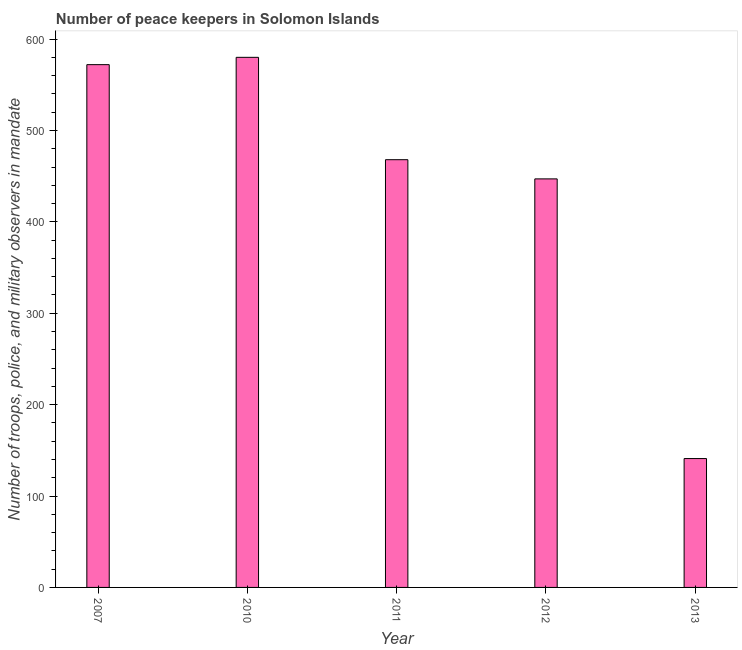Does the graph contain grids?
Your response must be concise. No. What is the title of the graph?
Give a very brief answer. Number of peace keepers in Solomon Islands. What is the label or title of the X-axis?
Keep it short and to the point. Year. What is the label or title of the Y-axis?
Provide a succinct answer. Number of troops, police, and military observers in mandate. What is the number of peace keepers in 2007?
Provide a succinct answer. 572. Across all years, what is the maximum number of peace keepers?
Provide a succinct answer. 580. Across all years, what is the minimum number of peace keepers?
Your response must be concise. 141. What is the sum of the number of peace keepers?
Your response must be concise. 2208. What is the difference between the number of peace keepers in 2007 and 2013?
Provide a short and direct response. 431. What is the average number of peace keepers per year?
Provide a short and direct response. 441. What is the median number of peace keepers?
Make the answer very short. 468. In how many years, is the number of peace keepers greater than 60 ?
Provide a short and direct response. 5. Do a majority of the years between 2010 and 2012 (inclusive) have number of peace keepers greater than 160 ?
Ensure brevity in your answer.  Yes. What is the ratio of the number of peace keepers in 2007 to that in 2013?
Give a very brief answer. 4.06. Is the number of peace keepers in 2007 less than that in 2012?
Offer a terse response. No. What is the difference between the highest and the lowest number of peace keepers?
Give a very brief answer. 439. In how many years, is the number of peace keepers greater than the average number of peace keepers taken over all years?
Provide a short and direct response. 4. Are all the bars in the graph horizontal?
Ensure brevity in your answer.  No. What is the difference between two consecutive major ticks on the Y-axis?
Your response must be concise. 100. Are the values on the major ticks of Y-axis written in scientific E-notation?
Your answer should be compact. No. What is the Number of troops, police, and military observers in mandate of 2007?
Your answer should be very brief. 572. What is the Number of troops, police, and military observers in mandate of 2010?
Your answer should be very brief. 580. What is the Number of troops, police, and military observers in mandate of 2011?
Provide a short and direct response. 468. What is the Number of troops, police, and military observers in mandate in 2012?
Keep it short and to the point. 447. What is the Number of troops, police, and military observers in mandate in 2013?
Keep it short and to the point. 141. What is the difference between the Number of troops, police, and military observers in mandate in 2007 and 2011?
Your answer should be very brief. 104. What is the difference between the Number of troops, police, and military observers in mandate in 2007 and 2012?
Keep it short and to the point. 125. What is the difference between the Number of troops, police, and military observers in mandate in 2007 and 2013?
Keep it short and to the point. 431. What is the difference between the Number of troops, police, and military observers in mandate in 2010 and 2011?
Provide a short and direct response. 112. What is the difference between the Number of troops, police, and military observers in mandate in 2010 and 2012?
Offer a terse response. 133. What is the difference between the Number of troops, police, and military observers in mandate in 2010 and 2013?
Your answer should be very brief. 439. What is the difference between the Number of troops, police, and military observers in mandate in 2011 and 2012?
Your answer should be compact. 21. What is the difference between the Number of troops, police, and military observers in mandate in 2011 and 2013?
Offer a terse response. 327. What is the difference between the Number of troops, police, and military observers in mandate in 2012 and 2013?
Provide a succinct answer. 306. What is the ratio of the Number of troops, police, and military observers in mandate in 2007 to that in 2010?
Provide a short and direct response. 0.99. What is the ratio of the Number of troops, police, and military observers in mandate in 2007 to that in 2011?
Provide a short and direct response. 1.22. What is the ratio of the Number of troops, police, and military observers in mandate in 2007 to that in 2012?
Provide a succinct answer. 1.28. What is the ratio of the Number of troops, police, and military observers in mandate in 2007 to that in 2013?
Your response must be concise. 4.06. What is the ratio of the Number of troops, police, and military observers in mandate in 2010 to that in 2011?
Your answer should be very brief. 1.24. What is the ratio of the Number of troops, police, and military observers in mandate in 2010 to that in 2012?
Give a very brief answer. 1.3. What is the ratio of the Number of troops, police, and military observers in mandate in 2010 to that in 2013?
Ensure brevity in your answer.  4.11. What is the ratio of the Number of troops, police, and military observers in mandate in 2011 to that in 2012?
Provide a short and direct response. 1.05. What is the ratio of the Number of troops, police, and military observers in mandate in 2011 to that in 2013?
Ensure brevity in your answer.  3.32. What is the ratio of the Number of troops, police, and military observers in mandate in 2012 to that in 2013?
Make the answer very short. 3.17. 